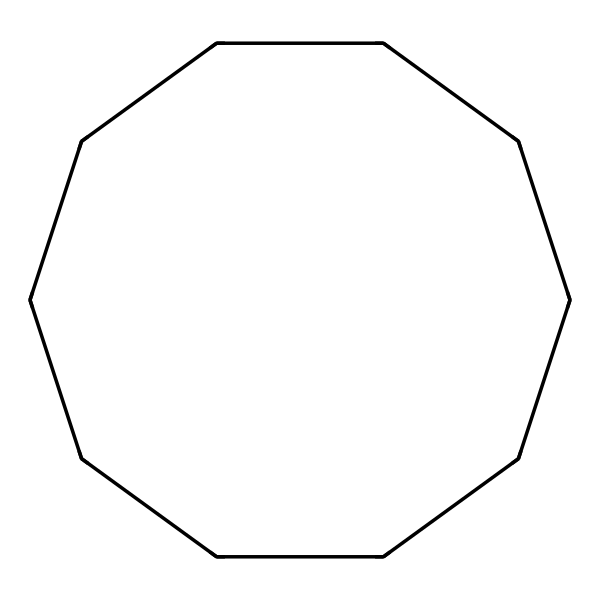What is the molecular formula of cyclodecane? The SMILES representation indicates a cyclic structure (C1) with 10 carbon atoms (C) connected in a ring, implying a formula of C10H20 after accounting for hydrogen atoms bonded to each carbon.
Answer: C10H20 How many carbon atoms are in the cyclodecane structure? By interpreting the SMILES notation, "C1CCCCCCCCC1" shows that there are 10 carbon atoms forming the structure, starting from C1 to the end of the chain before closing the ring.
Answer: 10 Is cyclodecane a saturated or unsaturated compound? Since cyclodecane is a cycloalkane and all carbon-carbon bonds are single bonds, meaning there are no double or triple bonds present, it is classified as saturated.
Answer: saturated What type of hybridization do the carbon atoms in cyclodecane exhibit? In cyclodecane, each carbon atom forms four single bonds with other carbons and hydrogens, which corresponds to sp3 hybridization in each carbon atom, typical for saturated hydrocarbons.
Answer: sp3 What is the bond angle in cyclodecane? Due to the tetrahedral geometry from the sp3 hybridization of the carbon atoms, the ideal bond angle between the carbon atoms is approximately 109.5 degrees.
Answer: 109.5 degrees Can cyclodecane be used as a solvent in personal care products? Cyclodecane's non-polar nature and ability to dissolve hydrophobic substances make it suitable for use as a solvent in personal care formulations.
Answer: yes 